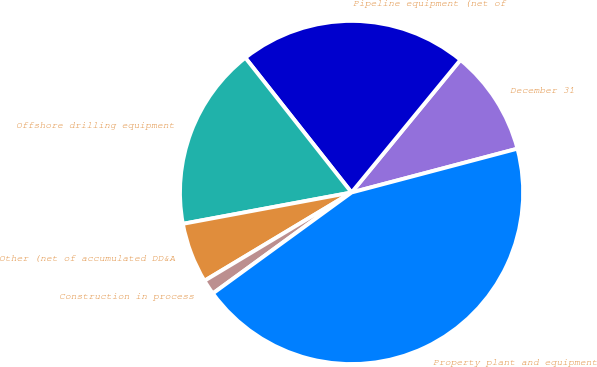Convert chart to OTSL. <chart><loc_0><loc_0><loc_500><loc_500><pie_chart><fcel>December 31<fcel>Pipeline equipment (net of<fcel>Offshore drilling equipment<fcel>Other (net of accumulated DD&A<fcel>Construction in process<fcel>Property plant and equipment<nl><fcel>9.95%<fcel>21.57%<fcel>17.3%<fcel>5.68%<fcel>1.41%<fcel>44.1%<nl></chart> 